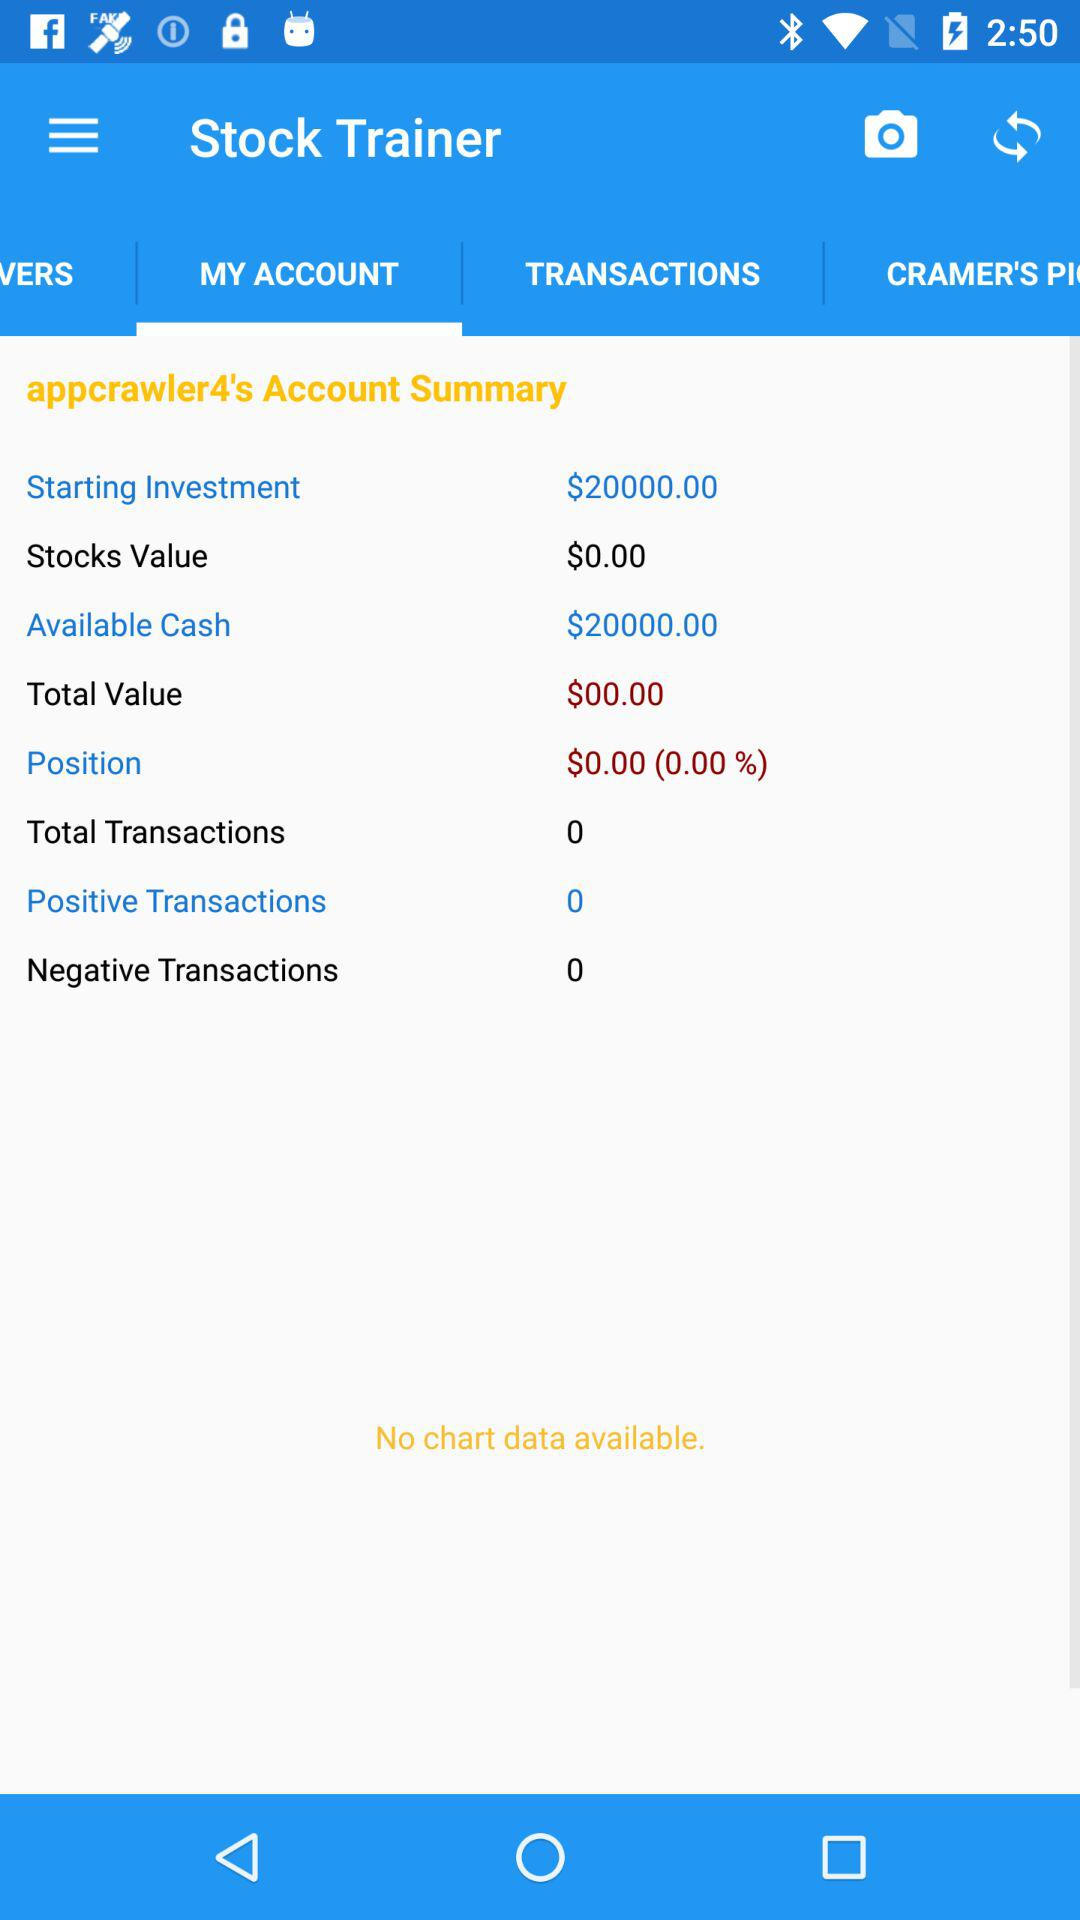How many positive transactions are there? There are 0 positive transactions. 